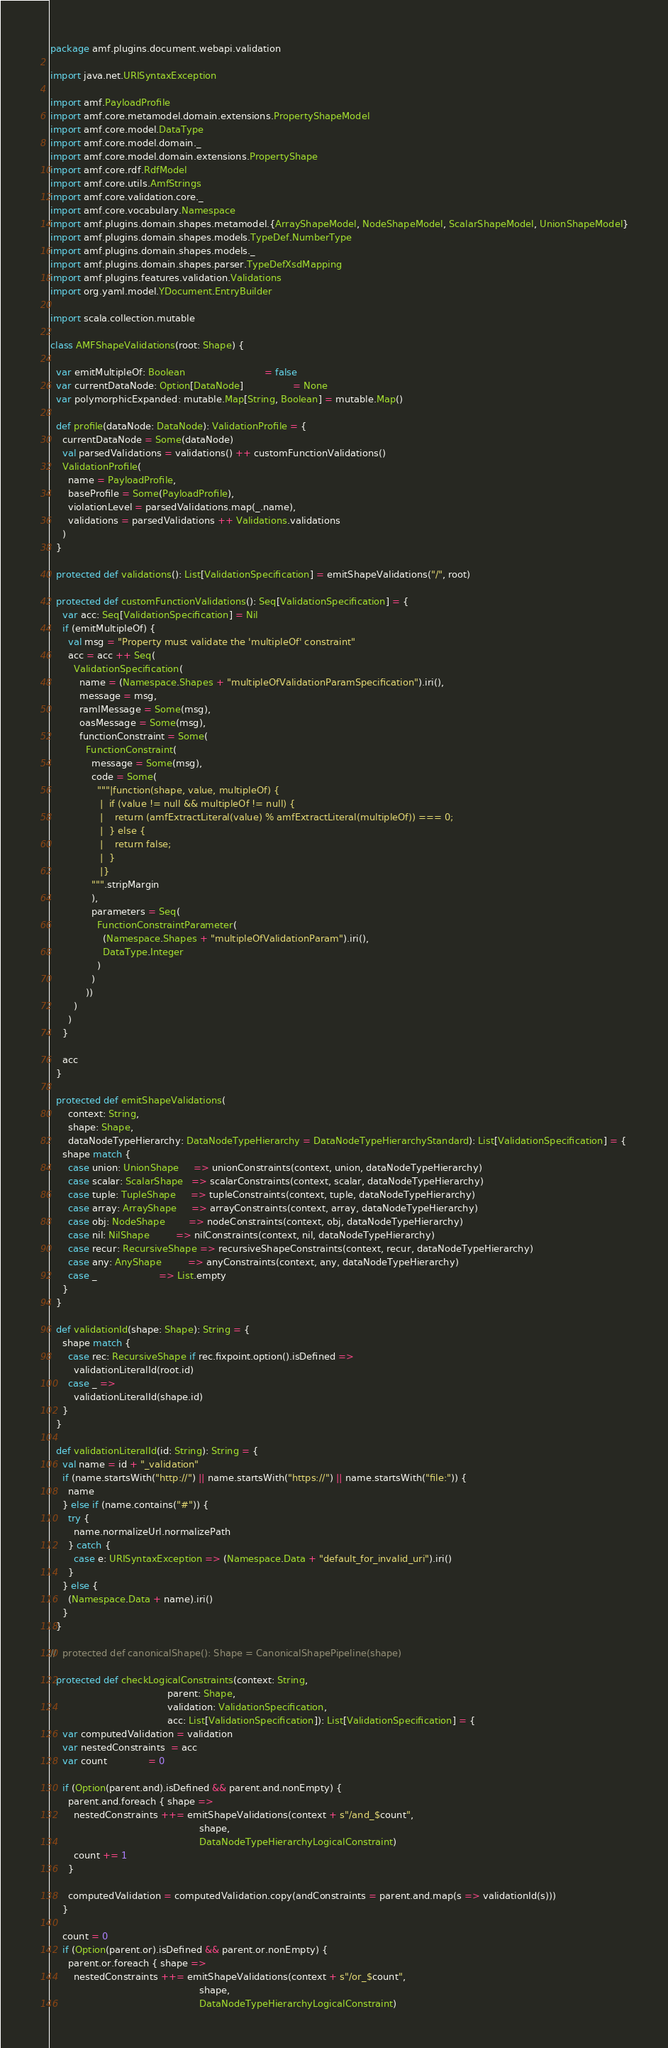<code> <loc_0><loc_0><loc_500><loc_500><_Scala_>package amf.plugins.document.webapi.validation

import java.net.URISyntaxException

import amf.PayloadProfile
import amf.core.metamodel.domain.extensions.PropertyShapeModel
import amf.core.model.DataType
import amf.core.model.domain._
import amf.core.model.domain.extensions.PropertyShape
import amf.core.rdf.RdfModel
import amf.core.utils.AmfStrings
import amf.core.validation.core._
import amf.core.vocabulary.Namespace
import amf.plugins.domain.shapes.metamodel.{ArrayShapeModel, NodeShapeModel, ScalarShapeModel, UnionShapeModel}
import amf.plugins.domain.shapes.models.TypeDef.NumberType
import amf.plugins.domain.shapes.models._
import amf.plugins.domain.shapes.parser.TypeDefXsdMapping
import amf.plugins.features.validation.Validations
import org.yaml.model.YDocument.EntryBuilder

import scala.collection.mutable

class AMFShapeValidations(root: Shape) {

  var emitMultipleOf: Boolean                           = false
  var currentDataNode: Option[DataNode]                 = None
  var polymorphicExpanded: mutable.Map[String, Boolean] = mutable.Map()

  def profile(dataNode: DataNode): ValidationProfile = {
    currentDataNode = Some(dataNode)
    val parsedValidations = validations() ++ customFunctionValidations()
    ValidationProfile(
      name = PayloadProfile,
      baseProfile = Some(PayloadProfile),
      violationLevel = parsedValidations.map(_.name),
      validations = parsedValidations ++ Validations.validations
    )
  }

  protected def validations(): List[ValidationSpecification] = emitShapeValidations("/", root)

  protected def customFunctionValidations(): Seq[ValidationSpecification] = {
    var acc: Seq[ValidationSpecification] = Nil
    if (emitMultipleOf) {
      val msg = "Property must validate the 'multipleOf' constraint"
      acc = acc ++ Seq(
        ValidationSpecification(
          name = (Namespace.Shapes + "multipleOfValidationParamSpecification").iri(),
          message = msg,
          ramlMessage = Some(msg),
          oasMessage = Some(msg),
          functionConstraint = Some(
            FunctionConstraint(
              message = Some(msg),
              code = Some(
                """|function(shape, value, multipleOf) {
                 |  if (value != null && multipleOf != null) {
                 |    return (amfExtractLiteral(value) % amfExtractLiteral(multipleOf)) === 0;
                 |  } else {
                 |    return false;
                 |  }
                 |}
              """.stripMargin
              ),
              parameters = Seq(
                FunctionConstraintParameter(
                  (Namespace.Shapes + "multipleOfValidationParam").iri(),
                  DataType.Integer
                )
              )
            ))
        )
      )
    }

    acc
  }

  protected def emitShapeValidations(
      context: String,
      shape: Shape,
      dataNodeTypeHierarchy: DataNodeTypeHierarchy = DataNodeTypeHierarchyStandard): List[ValidationSpecification] = {
    shape match {
      case union: UnionShape     => unionConstraints(context, union, dataNodeTypeHierarchy)
      case scalar: ScalarShape   => scalarConstraints(context, scalar, dataNodeTypeHierarchy)
      case tuple: TupleShape     => tupleConstraints(context, tuple, dataNodeTypeHierarchy)
      case array: ArrayShape     => arrayConstraints(context, array, dataNodeTypeHierarchy)
      case obj: NodeShape        => nodeConstraints(context, obj, dataNodeTypeHierarchy)
      case nil: NilShape         => nilConstraints(context, nil, dataNodeTypeHierarchy)
      case recur: RecursiveShape => recursiveShapeConstraints(context, recur, dataNodeTypeHierarchy)
      case any: AnyShape         => anyConstraints(context, any, dataNodeTypeHierarchy)
      case _                     => List.empty
    }
  }

  def validationId(shape: Shape): String = {
    shape match {
      case rec: RecursiveShape if rec.fixpoint.option().isDefined =>
        validationLiteralId(root.id)
      case _ =>
        validationLiteralId(shape.id)
    }
  }

  def validationLiteralId(id: String): String = {
    val name = id + "_validation"
    if (name.startsWith("http://") || name.startsWith("https://") || name.startsWith("file:")) {
      name
    } else if (name.contains("#")) {
      try {
        name.normalizeUrl.normalizePath
      } catch {
        case e: URISyntaxException => (Namespace.Data + "default_for_invalid_uri").iri()
      }
    } else {
      (Namespace.Data + name).iri()
    }
  }

//  protected def canonicalShape(): Shape = CanonicalShapePipeline(shape)

  protected def checkLogicalConstraints(context: String,
                                        parent: Shape,
                                        validation: ValidationSpecification,
                                        acc: List[ValidationSpecification]): List[ValidationSpecification] = {
    var computedValidation = validation
    var nestedConstraints  = acc
    var count              = 0

    if (Option(parent.and).isDefined && parent.and.nonEmpty) {
      parent.and.foreach { shape =>
        nestedConstraints ++= emitShapeValidations(context + s"/and_$count",
                                                   shape,
                                                   DataNodeTypeHierarchyLogicalConstraint)
        count += 1
      }

      computedValidation = computedValidation.copy(andConstraints = parent.and.map(s => validationId(s)))
    }

    count = 0
    if (Option(parent.or).isDefined && parent.or.nonEmpty) {
      parent.or.foreach { shape =>
        nestedConstraints ++= emitShapeValidations(context + s"/or_$count",
                                                   shape,
                                                   DataNodeTypeHierarchyLogicalConstraint)</code> 